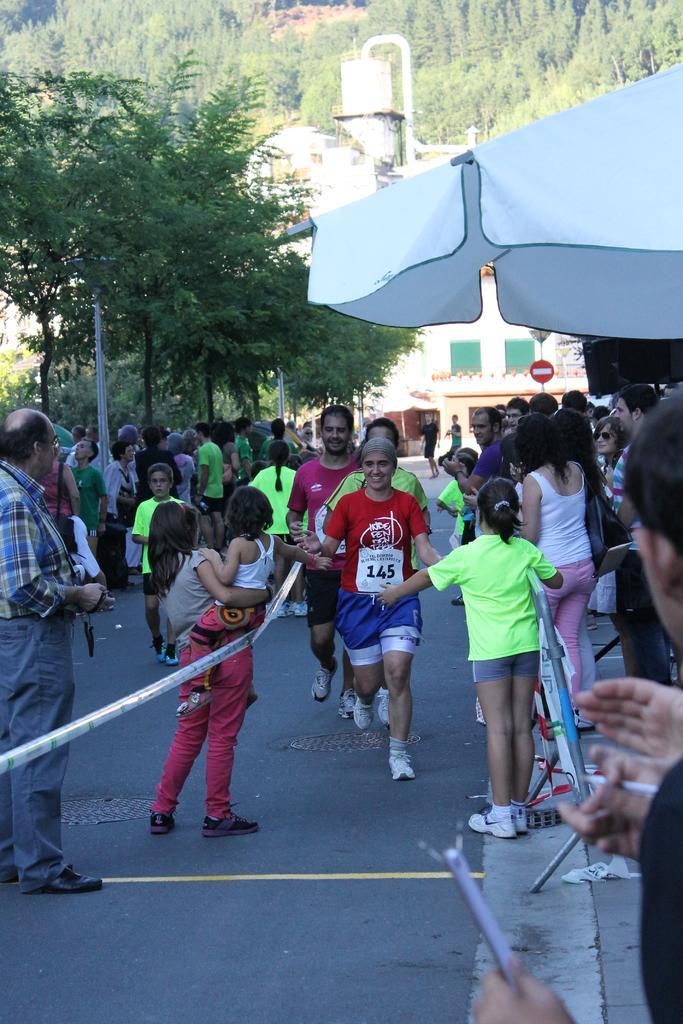Describe this image in one or two sentences. At the bottom of this image, there are persons on the road, there is a thread and there are persons on a footpath, above them there is a white color tent. In the background, there are trees, buildings and a mountain. 